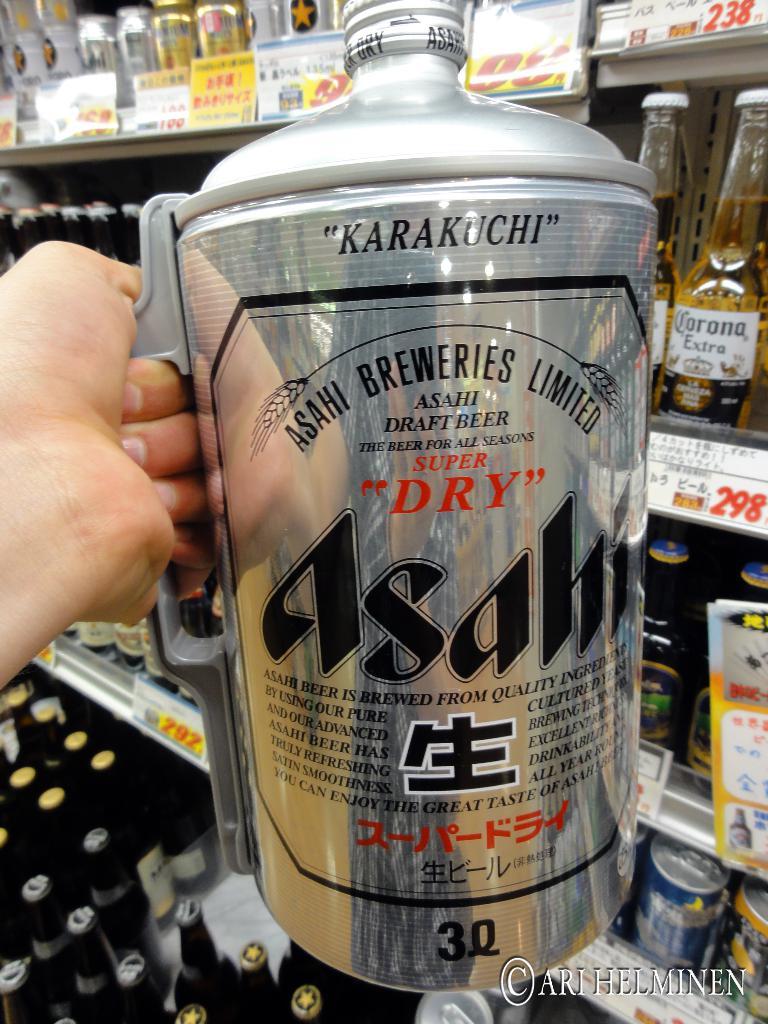What is the name of the limited edition?
Provide a succinct answer. Asahi. What is the best season for this beer?
Make the answer very short. All seasons. 